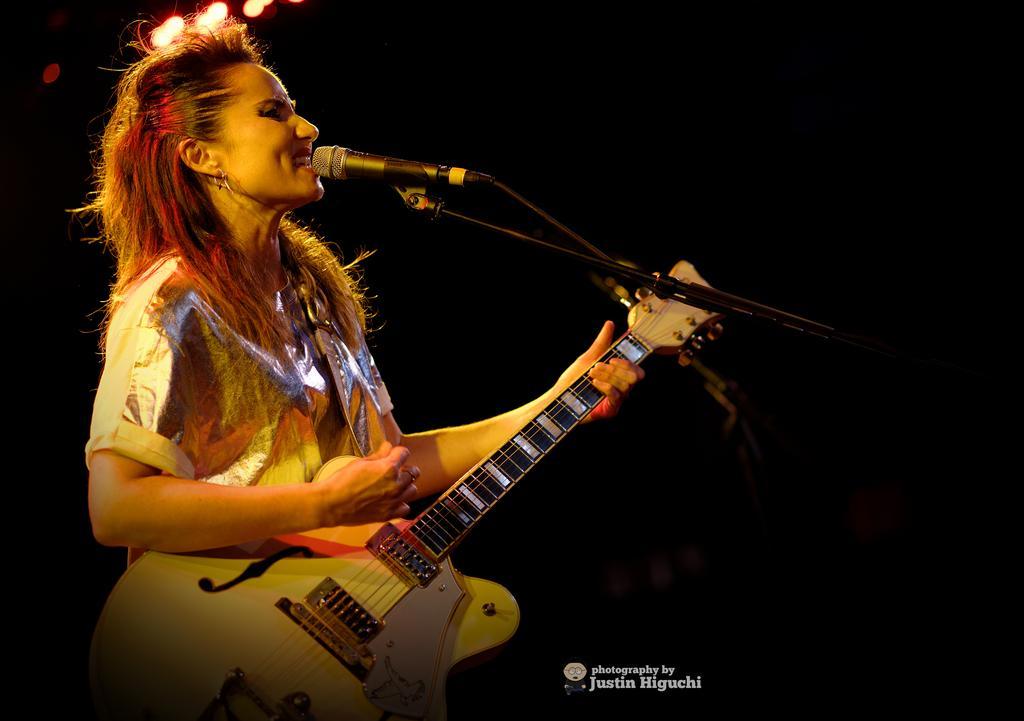Describe this image in one or two sentences. In this picture we can see a women who is singing on the mike and she is playing guitar. 